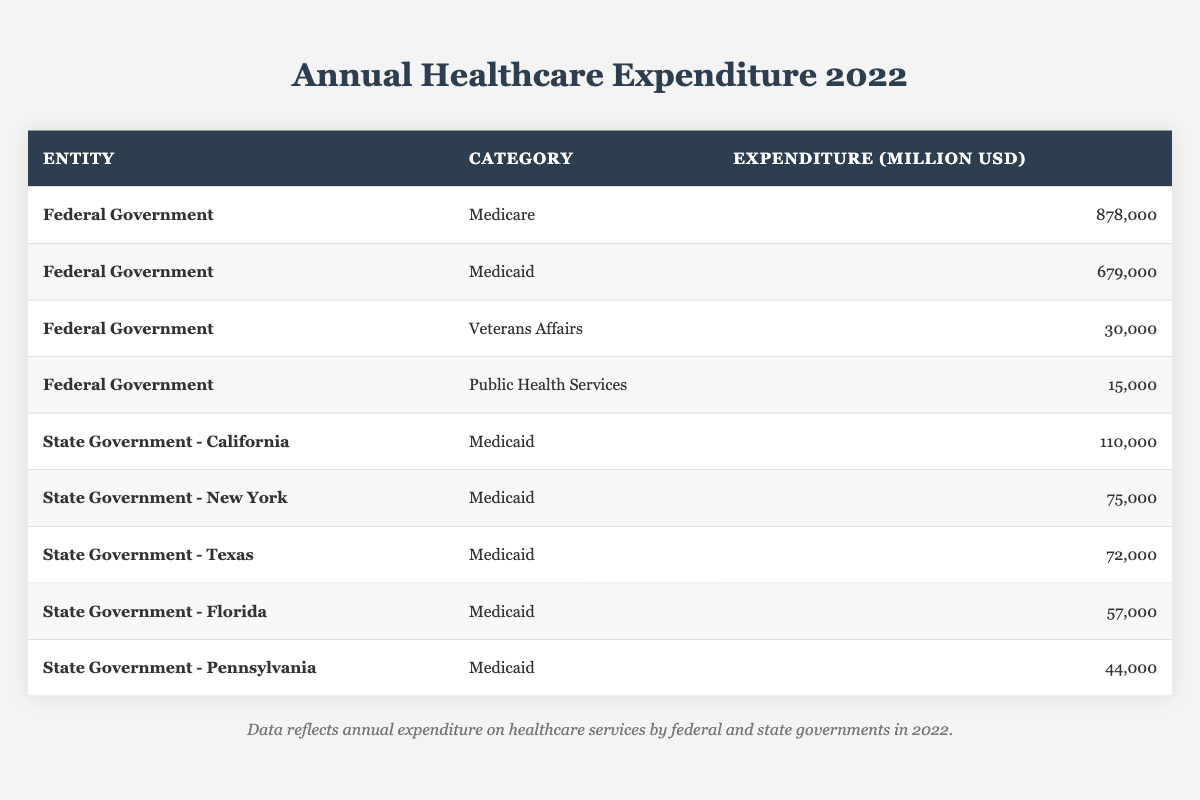What is the total healthcare expenditure by the Federal Government? To find the total expenditure by the Federal Government, we need to add all the categories listed for this entity in the table. This includes Medicare (878,000), Medicaid (679,000), Veterans Affairs (30,000), and Public Health Services (15,000). The total is 878,000 + 679,000 + 30,000 + 15,000 = 1,602,000 million USD.
Answer: 1,602,000 million USD How much more did the Federal Government spend on Medicare than on Veterans Affairs? To find the difference, we subtract the expenditure for Veterans Affairs (30,000) from Medicare (878,000). The calculation is 878,000 - 30,000 = 848,000 million USD.
Answer: 848,000 million USD What is the expenditure on Medicaid by State Government - California? According to the table, the expenditure on Medicaid by the State Government - California is listed as 110,000 million USD.
Answer: 110,000 million USD Which category received the least funding from the Federal Government? The categories listed for the Federal Government include Medicare, Medicaid, Veterans Affairs, and Public Health Services. Among these, Public Health Services received the least funding at 15,000 million USD.
Answer: Public Health Services What is the total Medicaid expenditure across all listed state governments? To calculate the total Medicaid expenditure, we add the figures from California (110,000), New York (75,000), Texas (72,000), Florida (57,000), and Pennsylvania (44,000). The total is 110,000 + 75,000 + 72,000 + 57,000 + 44,000 = 358,000 million USD.
Answer: 358,000 million USD Is the Federal Government's spending on Medicaid greater than the combined Medicaid expenditure of New York and Texas? First, we find the Federal Government's Medicaid expenditure, which is 679,000 million USD. Next, we calculate the combined Medicaid spending of New York (75,000) and Texas (72,000), which is 75,000 + 72,000 = 147,000 million USD. Since 679,000 is greater than 147,000, the answer is yes.
Answer: Yes What is the average expenditure on Medicaid among the state governments listed? To find the average, we first need to sum the Medicaid expenditures of California (110,000), New York (75,000), Texas (72,000), Florida (57,000), and Pennsylvania (44,000), which totals 358,000 million USD. Then, we divide this sum by the number of states (5): 358,000 / 5 = 71,600 million USD.
Answer: 71,600 million USD Which entity has the highest single category expenditure? Reviewing the expenditures, the Federal Government’s Medicare spending of 878,000 million USD is the highest among all entities and categories listed.
Answer: Federal Government (Medicare) 